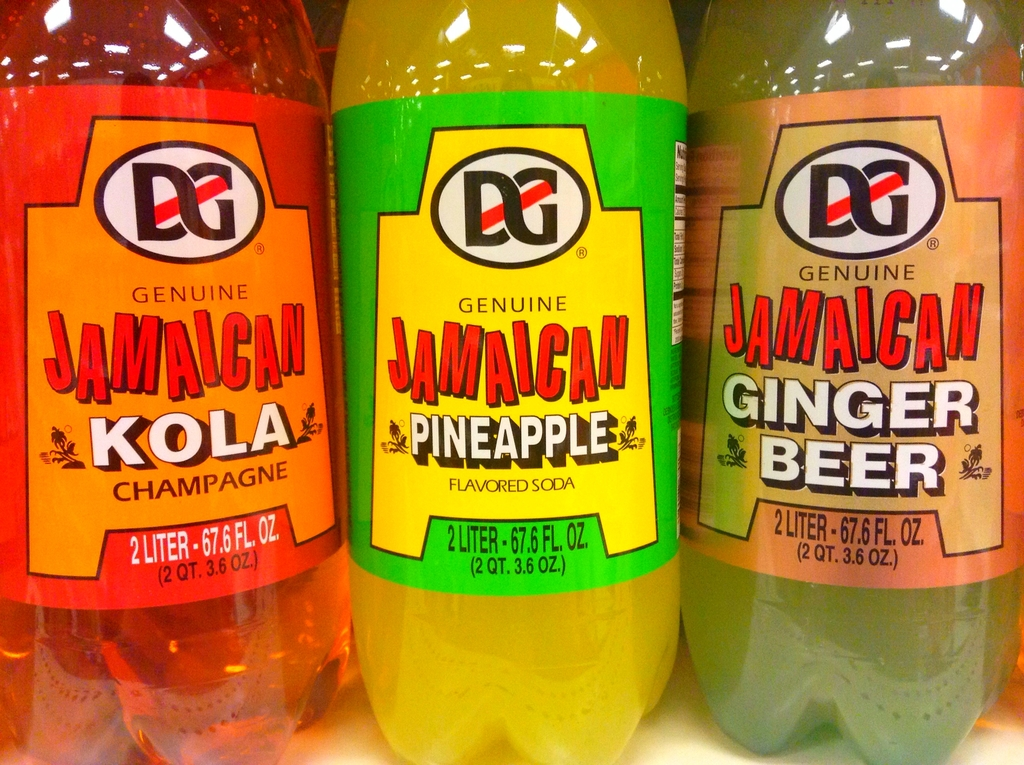Provide a one-sentence caption for the provided image.
Reference OCR token: DG, DG, DG, GENUINE, GENUINE, JAMAICAN, GENUINE, JAMAICAN, JAMAICAN, KOLA, PINEAPPLE, GINGER, CHAMPAGNE, FLAVOREDSODA, SODA, BEER, 2LITER-67.6FL.OZ, 2LITER, 2LITER-67.6FL.OZ, 2LITER, 67.6FL., OZ., QT.3.6OZ, (2QT.3.6.OZ.), (2QT., 3.6.OZ.) The image shows three 2-liter bottles of 'Genuine Jamaican' branded sodas, distinctly flavored as Kola Champagne, Pineapple, and Ginger Beer, presented with vibrant color-coded labels. 